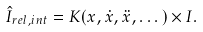<formula> <loc_0><loc_0><loc_500><loc_500>\hat { I } _ { r e l , i n t } = K ( x , \dot { x } , \ddot { x } , \dots ) \times I .</formula> 